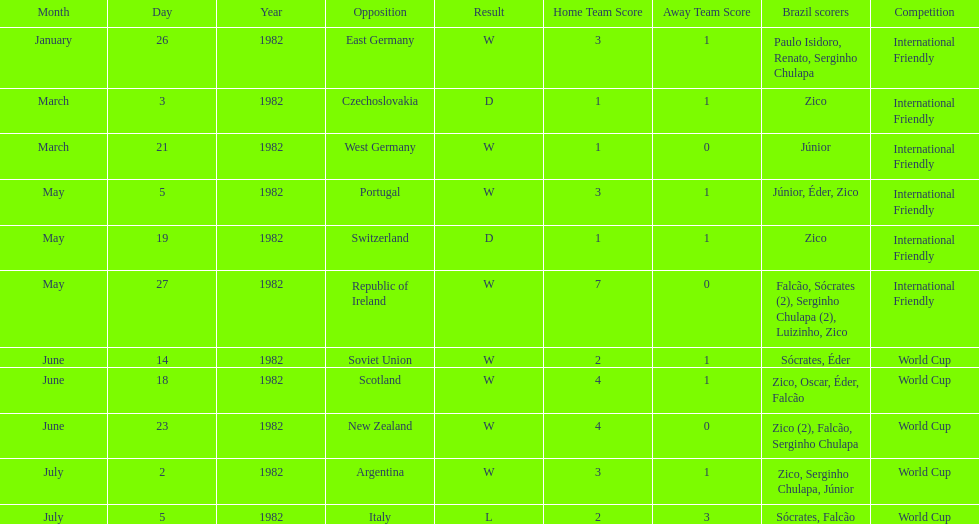How many games did this team play in 1982? 11. 